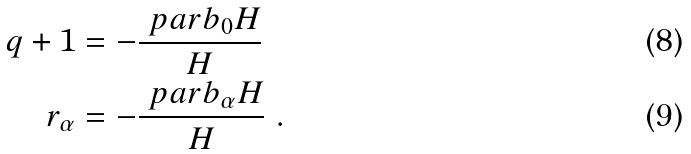<formula> <loc_0><loc_0><loc_500><loc_500>q + 1 & = - \frac { \ p a r b _ { 0 } H } { H } \\ r _ { \alpha } & = - \frac { \ p a r b _ { \alpha } H } { H } \ .</formula> 